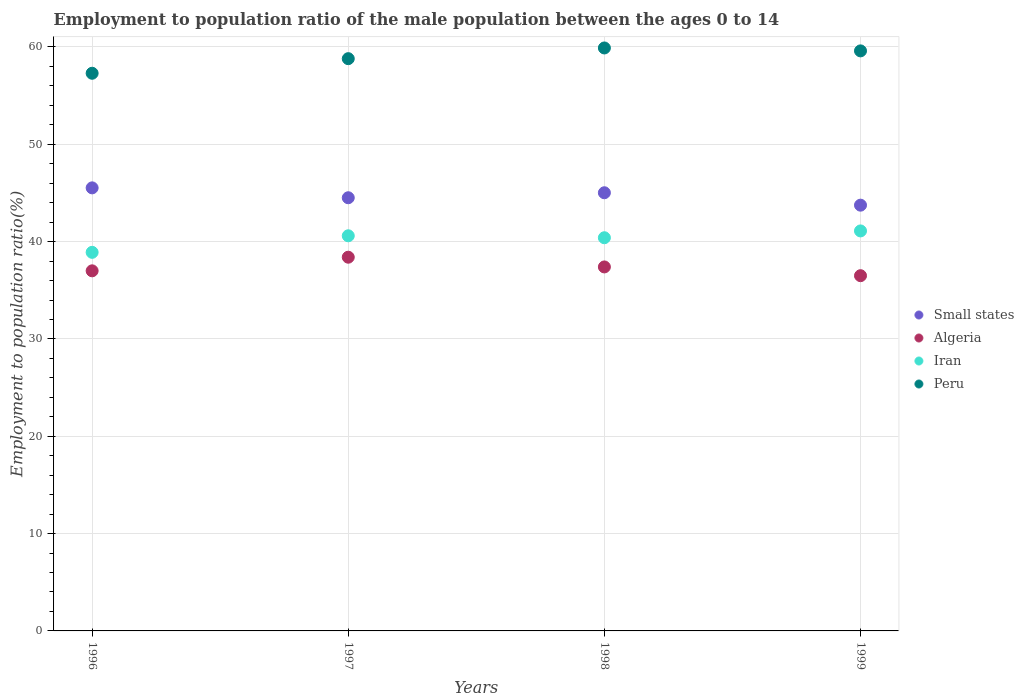How many different coloured dotlines are there?
Ensure brevity in your answer.  4. What is the employment to population ratio in Iran in 1996?
Your answer should be very brief. 38.9. Across all years, what is the maximum employment to population ratio in Small states?
Offer a very short reply. 45.52. Across all years, what is the minimum employment to population ratio in Iran?
Offer a very short reply. 38.9. In which year was the employment to population ratio in Peru maximum?
Make the answer very short. 1998. What is the total employment to population ratio in Small states in the graph?
Give a very brief answer. 178.8. What is the difference between the employment to population ratio in Peru in 1996 and that in 1998?
Provide a short and direct response. -2.6. What is the difference between the employment to population ratio in Algeria in 1998 and the employment to population ratio in Iran in 1997?
Offer a terse response. -3.2. What is the average employment to population ratio in Peru per year?
Provide a succinct answer. 58.9. In the year 1997, what is the difference between the employment to population ratio in Small states and employment to population ratio in Peru?
Your response must be concise. -14.29. In how many years, is the employment to population ratio in Algeria greater than 22 %?
Provide a succinct answer. 4. What is the ratio of the employment to population ratio in Small states in 1997 to that in 1998?
Your answer should be very brief. 0.99. Is the difference between the employment to population ratio in Small states in 1996 and 1997 greater than the difference between the employment to population ratio in Peru in 1996 and 1997?
Keep it short and to the point. Yes. What is the difference between the highest and the second highest employment to population ratio in Iran?
Your response must be concise. 0.5. What is the difference between the highest and the lowest employment to population ratio in Peru?
Provide a succinct answer. 2.6. In how many years, is the employment to population ratio in Iran greater than the average employment to population ratio in Iran taken over all years?
Give a very brief answer. 3. How many dotlines are there?
Make the answer very short. 4. How many years are there in the graph?
Your answer should be very brief. 4. Are the values on the major ticks of Y-axis written in scientific E-notation?
Offer a terse response. No. How are the legend labels stacked?
Give a very brief answer. Vertical. What is the title of the graph?
Ensure brevity in your answer.  Employment to population ratio of the male population between the ages 0 to 14. What is the label or title of the X-axis?
Your answer should be very brief. Years. What is the label or title of the Y-axis?
Keep it short and to the point. Employment to population ratio(%). What is the Employment to population ratio(%) of Small states in 1996?
Give a very brief answer. 45.52. What is the Employment to population ratio(%) of Algeria in 1996?
Keep it short and to the point. 37. What is the Employment to population ratio(%) of Iran in 1996?
Your response must be concise. 38.9. What is the Employment to population ratio(%) in Peru in 1996?
Give a very brief answer. 57.3. What is the Employment to population ratio(%) of Small states in 1997?
Provide a succinct answer. 44.51. What is the Employment to population ratio(%) of Algeria in 1997?
Give a very brief answer. 38.4. What is the Employment to population ratio(%) of Iran in 1997?
Give a very brief answer. 40.6. What is the Employment to population ratio(%) of Peru in 1997?
Make the answer very short. 58.8. What is the Employment to population ratio(%) of Small states in 1998?
Your answer should be very brief. 45.02. What is the Employment to population ratio(%) of Algeria in 1998?
Ensure brevity in your answer.  37.4. What is the Employment to population ratio(%) of Iran in 1998?
Provide a succinct answer. 40.4. What is the Employment to population ratio(%) of Peru in 1998?
Provide a succinct answer. 59.9. What is the Employment to population ratio(%) in Small states in 1999?
Ensure brevity in your answer.  43.75. What is the Employment to population ratio(%) in Algeria in 1999?
Give a very brief answer. 36.5. What is the Employment to population ratio(%) of Iran in 1999?
Your answer should be very brief. 41.1. What is the Employment to population ratio(%) in Peru in 1999?
Your response must be concise. 59.6. Across all years, what is the maximum Employment to population ratio(%) of Small states?
Offer a very short reply. 45.52. Across all years, what is the maximum Employment to population ratio(%) in Algeria?
Offer a very short reply. 38.4. Across all years, what is the maximum Employment to population ratio(%) in Iran?
Your response must be concise. 41.1. Across all years, what is the maximum Employment to population ratio(%) of Peru?
Offer a terse response. 59.9. Across all years, what is the minimum Employment to population ratio(%) in Small states?
Make the answer very short. 43.75. Across all years, what is the minimum Employment to population ratio(%) in Algeria?
Provide a short and direct response. 36.5. Across all years, what is the minimum Employment to population ratio(%) of Iran?
Your response must be concise. 38.9. Across all years, what is the minimum Employment to population ratio(%) of Peru?
Your answer should be very brief. 57.3. What is the total Employment to population ratio(%) of Small states in the graph?
Make the answer very short. 178.8. What is the total Employment to population ratio(%) in Algeria in the graph?
Offer a very short reply. 149.3. What is the total Employment to population ratio(%) of Iran in the graph?
Ensure brevity in your answer.  161. What is the total Employment to population ratio(%) of Peru in the graph?
Your answer should be very brief. 235.6. What is the difference between the Employment to population ratio(%) in Small states in 1996 and that in 1997?
Offer a very short reply. 1.02. What is the difference between the Employment to population ratio(%) of Algeria in 1996 and that in 1997?
Offer a terse response. -1.4. What is the difference between the Employment to population ratio(%) in Peru in 1996 and that in 1997?
Your answer should be compact. -1.5. What is the difference between the Employment to population ratio(%) of Small states in 1996 and that in 1998?
Provide a short and direct response. 0.5. What is the difference between the Employment to population ratio(%) in Iran in 1996 and that in 1998?
Keep it short and to the point. -1.5. What is the difference between the Employment to population ratio(%) in Small states in 1996 and that in 1999?
Keep it short and to the point. 1.78. What is the difference between the Employment to population ratio(%) of Iran in 1996 and that in 1999?
Your answer should be compact. -2.2. What is the difference between the Employment to population ratio(%) of Peru in 1996 and that in 1999?
Your response must be concise. -2.3. What is the difference between the Employment to population ratio(%) of Small states in 1997 and that in 1998?
Provide a succinct answer. -0.51. What is the difference between the Employment to population ratio(%) of Algeria in 1997 and that in 1998?
Offer a terse response. 1. What is the difference between the Employment to population ratio(%) of Small states in 1997 and that in 1999?
Make the answer very short. 0.76. What is the difference between the Employment to population ratio(%) of Algeria in 1997 and that in 1999?
Keep it short and to the point. 1.9. What is the difference between the Employment to population ratio(%) in Iran in 1997 and that in 1999?
Your answer should be compact. -0.5. What is the difference between the Employment to population ratio(%) in Small states in 1998 and that in 1999?
Give a very brief answer. 1.27. What is the difference between the Employment to population ratio(%) in Small states in 1996 and the Employment to population ratio(%) in Algeria in 1997?
Make the answer very short. 7.12. What is the difference between the Employment to population ratio(%) of Small states in 1996 and the Employment to population ratio(%) of Iran in 1997?
Ensure brevity in your answer.  4.92. What is the difference between the Employment to population ratio(%) of Small states in 1996 and the Employment to population ratio(%) of Peru in 1997?
Offer a terse response. -13.28. What is the difference between the Employment to population ratio(%) of Algeria in 1996 and the Employment to population ratio(%) of Iran in 1997?
Offer a terse response. -3.6. What is the difference between the Employment to population ratio(%) in Algeria in 1996 and the Employment to population ratio(%) in Peru in 1997?
Offer a very short reply. -21.8. What is the difference between the Employment to population ratio(%) of Iran in 1996 and the Employment to population ratio(%) of Peru in 1997?
Your answer should be compact. -19.9. What is the difference between the Employment to population ratio(%) of Small states in 1996 and the Employment to population ratio(%) of Algeria in 1998?
Make the answer very short. 8.12. What is the difference between the Employment to population ratio(%) in Small states in 1996 and the Employment to population ratio(%) in Iran in 1998?
Give a very brief answer. 5.12. What is the difference between the Employment to population ratio(%) of Small states in 1996 and the Employment to population ratio(%) of Peru in 1998?
Ensure brevity in your answer.  -14.38. What is the difference between the Employment to population ratio(%) of Algeria in 1996 and the Employment to population ratio(%) of Peru in 1998?
Keep it short and to the point. -22.9. What is the difference between the Employment to population ratio(%) of Small states in 1996 and the Employment to population ratio(%) of Algeria in 1999?
Provide a succinct answer. 9.02. What is the difference between the Employment to population ratio(%) in Small states in 1996 and the Employment to population ratio(%) in Iran in 1999?
Your response must be concise. 4.42. What is the difference between the Employment to population ratio(%) in Small states in 1996 and the Employment to population ratio(%) in Peru in 1999?
Ensure brevity in your answer.  -14.08. What is the difference between the Employment to population ratio(%) in Algeria in 1996 and the Employment to population ratio(%) in Peru in 1999?
Provide a short and direct response. -22.6. What is the difference between the Employment to population ratio(%) in Iran in 1996 and the Employment to population ratio(%) in Peru in 1999?
Ensure brevity in your answer.  -20.7. What is the difference between the Employment to population ratio(%) of Small states in 1997 and the Employment to population ratio(%) of Algeria in 1998?
Ensure brevity in your answer.  7.11. What is the difference between the Employment to population ratio(%) in Small states in 1997 and the Employment to population ratio(%) in Iran in 1998?
Your answer should be very brief. 4.11. What is the difference between the Employment to population ratio(%) in Small states in 1997 and the Employment to population ratio(%) in Peru in 1998?
Your answer should be very brief. -15.39. What is the difference between the Employment to population ratio(%) in Algeria in 1997 and the Employment to population ratio(%) in Iran in 1998?
Offer a very short reply. -2. What is the difference between the Employment to population ratio(%) in Algeria in 1997 and the Employment to population ratio(%) in Peru in 1998?
Your response must be concise. -21.5. What is the difference between the Employment to population ratio(%) in Iran in 1997 and the Employment to population ratio(%) in Peru in 1998?
Your answer should be very brief. -19.3. What is the difference between the Employment to population ratio(%) in Small states in 1997 and the Employment to population ratio(%) in Algeria in 1999?
Provide a succinct answer. 8.01. What is the difference between the Employment to population ratio(%) of Small states in 1997 and the Employment to population ratio(%) of Iran in 1999?
Provide a short and direct response. 3.41. What is the difference between the Employment to population ratio(%) in Small states in 1997 and the Employment to population ratio(%) in Peru in 1999?
Offer a very short reply. -15.09. What is the difference between the Employment to population ratio(%) of Algeria in 1997 and the Employment to population ratio(%) of Iran in 1999?
Offer a very short reply. -2.7. What is the difference between the Employment to population ratio(%) of Algeria in 1997 and the Employment to population ratio(%) of Peru in 1999?
Ensure brevity in your answer.  -21.2. What is the difference between the Employment to population ratio(%) of Small states in 1998 and the Employment to population ratio(%) of Algeria in 1999?
Your response must be concise. 8.52. What is the difference between the Employment to population ratio(%) of Small states in 1998 and the Employment to population ratio(%) of Iran in 1999?
Give a very brief answer. 3.92. What is the difference between the Employment to population ratio(%) of Small states in 1998 and the Employment to population ratio(%) of Peru in 1999?
Give a very brief answer. -14.58. What is the difference between the Employment to population ratio(%) in Algeria in 1998 and the Employment to population ratio(%) in Iran in 1999?
Ensure brevity in your answer.  -3.7. What is the difference between the Employment to population ratio(%) in Algeria in 1998 and the Employment to population ratio(%) in Peru in 1999?
Keep it short and to the point. -22.2. What is the difference between the Employment to population ratio(%) in Iran in 1998 and the Employment to population ratio(%) in Peru in 1999?
Ensure brevity in your answer.  -19.2. What is the average Employment to population ratio(%) of Small states per year?
Offer a very short reply. 44.7. What is the average Employment to population ratio(%) of Algeria per year?
Offer a terse response. 37.33. What is the average Employment to population ratio(%) of Iran per year?
Provide a succinct answer. 40.25. What is the average Employment to population ratio(%) in Peru per year?
Your response must be concise. 58.9. In the year 1996, what is the difference between the Employment to population ratio(%) of Small states and Employment to population ratio(%) of Algeria?
Offer a terse response. 8.52. In the year 1996, what is the difference between the Employment to population ratio(%) of Small states and Employment to population ratio(%) of Iran?
Your answer should be compact. 6.62. In the year 1996, what is the difference between the Employment to population ratio(%) of Small states and Employment to population ratio(%) of Peru?
Ensure brevity in your answer.  -11.78. In the year 1996, what is the difference between the Employment to population ratio(%) in Algeria and Employment to population ratio(%) in Iran?
Your answer should be very brief. -1.9. In the year 1996, what is the difference between the Employment to population ratio(%) in Algeria and Employment to population ratio(%) in Peru?
Keep it short and to the point. -20.3. In the year 1996, what is the difference between the Employment to population ratio(%) of Iran and Employment to population ratio(%) of Peru?
Your answer should be compact. -18.4. In the year 1997, what is the difference between the Employment to population ratio(%) in Small states and Employment to population ratio(%) in Algeria?
Make the answer very short. 6.11. In the year 1997, what is the difference between the Employment to population ratio(%) in Small states and Employment to population ratio(%) in Iran?
Your response must be concise. 3.91. In the year 1997, what is the difference between the Employment to population ratio(%) in Small states and Employment to population ratio(%) in Peru?
Make the answer very short. -14.29. In the year 1997, what is the difference between the Employment to population ratio(%) of Algeria and Employment to population ratio(%) of Iran?
Offer a very short reply. -2.2. In the year 1997, what is the difference between the Employment to population ratio(%) of Algeria and Employment to population ratio(%) of Peru?
Provide a succinct answer. -20.4. In the year 1997, what is the difference between the Employment to population ratio(%) of Iran and Employment to population ratio(%) of Peru?
Ensure brevity in your answer.  -18.2. In the year 1998, what is the difference between the Employment to population ratio(%) in Small states and Employment to population ratio(%) in Algeria?
Make the answer very short. 7.62. In the year 1998, what is the difference between the Employment to population ratio(%) in Small states and Employment to population ratio(%) in Iran?
Ensure brevity in your answer.  4.62. In the year 1998, what is the difference between the Employment to population ratio(%) of Small states and Employment to population ratio(%) of Peru?
Your answer should be very brief. -14.88. In the year 1998, what is the difference between the Employment to population ratio(%) in Algeria and Employment to population ratio(%) in Iran?
Provide a short and direct response. -3. In the year 1998, what is the difference between the Employment to population ratio(%) of Algeria and Employment to population ratio(%) of Peru?
Offer a very short reply. -22.5. In the year 1998, what is the difference between the Employment to population ratio(%) of Iran and Employment to population ratio(%) of Peru?
Offer a very short reply. -19.5. In the year 1999, what is the difference between the Employment to population ratio(%) in Small states and Employment to population ratio(%) in Algeria?
Keep it short and to the point. 7.25. In the year 1999, what is the difference between the Employment to population ratio(%) in Small states and Employment to population ratio(%) in Iran?
Your answer should be very brief. 2.65. In the year 1999, what is the difference between the Employment to population ratio(%) in Small states and Employment to population ratio(%) in Peru?
Your answer should be very brief. -15.85. In the year 1999, what is the difference between the Employment to population ratio(%) in Algeria and Employment to population ratio(%) in Peru?
Provide a succinct answer. -23.1. In the year 1999, what is the difference between the Employment to population ratio(%) in Iran and Employment to population ratio(%) in Peru?
Your answer should be compact. -18.5. What is the ratio of the Employment to population ratio(%) of Small states in 1996 to that in 1997?
Offer a terse response. 1.02. What is the ratio of the Employment to population ratio(%) in Algeria in 1996 to that in 1997?
Ensure brevity in your answer.  0.96. What is the ratio of the Employment to population ratio(%) in Iran in 1996 to that in 1997?
Your answer should be very brief. 0.96. What is the ratio of the Employment to population ratio(%) of Peru in 1996 to that in 1997?
Your answer should be compact. 0.97. What is the ratio of the Employment to population ratio(%) in Small states in 1996 to that in 1998?
Your answer should be compact. 1.01. What is the ratio of the Employment to population ratio(%) in Algeria in 1996 to that in 1998?
Make the answer very short. 0.99. What is the ratio of the Employment to population ratio(%) of Iran in 1996 to that in 1998?
Offer a terse response. 0.96. What is the ratio of the Employment to population ratio(%) in Peru in 1996 to that in 1998?
Offer a terse response. 0.96. What is the ratio of the Employment to population ratio(%) in Small states in 1996 to that in 1999?
Your answer should be compact. 1.04. What is the ratio of the Employment to population ratio(%) of Algeria in 1996 to that in 1999?
Offer a terse response. 1.01. What is the ratio of the Employment to population ratio(%) in Iran in 1996 to that in 1999?
Offer a terse response. 0.95. What is the ratio of the Employment to population ratio(%) in Peru in 1996 to that in 1999?
Provide a short and direct response. 0.96. What is the ratio of the Employment to population ratio(%) in Small states in 1997 to that in 1998?
Ensure brevity in your answer.  0.99. What is the ratio of the Employment to population ratio(%) of Algeria in 1997 to that in 1998?
Provide a short and direct response. 1.03. What is the ratio of the Employment to population ratio(%) in Iran in 1997 to that in 1998?
Make the answer very short. 1. What is the ratio of the Employment to population ratio(%) in Peru in 1997 to that in 1998?
Your answer should be very brief. 0.98. What is the ratio of the Employment to population ratio(%) of Small states in 1997 to that in 1999?
Provide a short and direct response. 1.02. What is the ratio of the Employment to population ratio(%) of Algeria in 1997 to that in 1999?
Provide a short and direct response. 1.05. What is the ratio of the Employment to population ratio(%) of Peru in 1997 to that in 1999?
Your answer should be very brief. 0.99. What is the ratio of the Employment to population ratio(%) of Small states in 1998 to that in 1999?
Your answer should be very brief. 1.03. What is the ratio of the Employment to population ratio(%) of Algeria in 1998 to that in 1999?
Your response must be concise. 1.02. What is the ratio of the Employment to population ratio(%) of Peru in 1998 to that in 1999?
Make the answer very short. 1. What is the difference between the highest and the second highest Employment to population ratio(%) in Small states?
Offer a very short reply. 0.5. What is the difference between the highest and the second highest Employment to population ratio(%) in Algeria?
Ensure brevity in your answer.  1. What is the difference between the highest and the second highest Employment to population ratio(%) of Iran?
Provide a succinct answer. 0.5. What is the difference between the highest and the lowest Employment to population ratio(%) in Small states?
Your response must be concise. 1.78. What is the difference between the highest and the lowest Employment to population ratio(%) in Iran?
Keep it short and to the point. 2.2. 